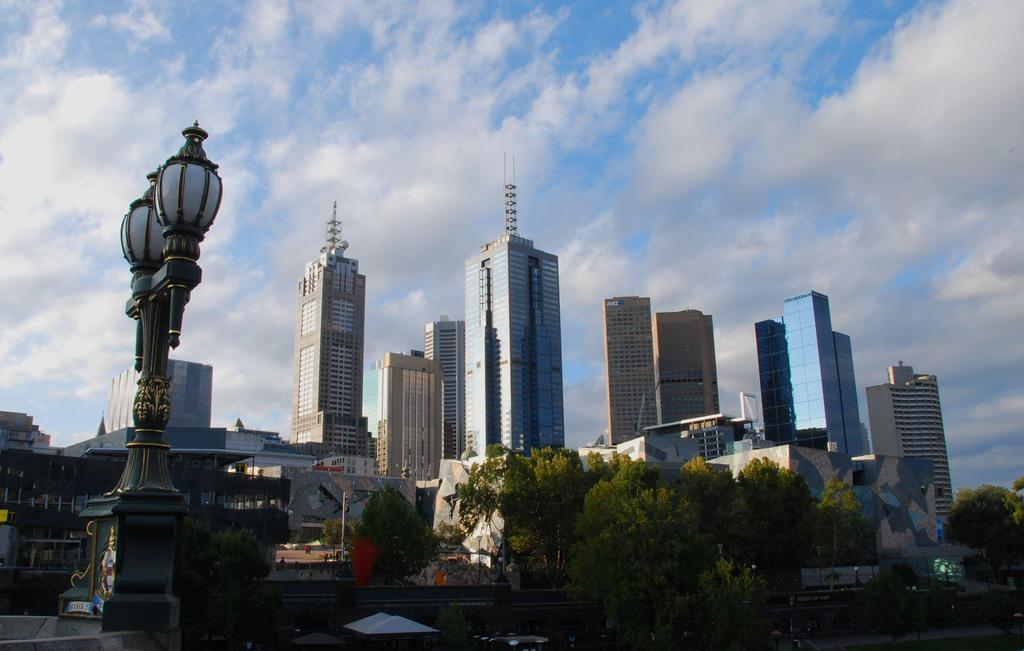What types of structures can be seen in the image? There are different shaped buildings in the image. What can be seen illuminating the area in the image? Street lights are present in the image. What type of natural elements are visible in the image? Trees are visible in the image. Where is the toothbrush located in the image? There is no toothbrush present in the image. 